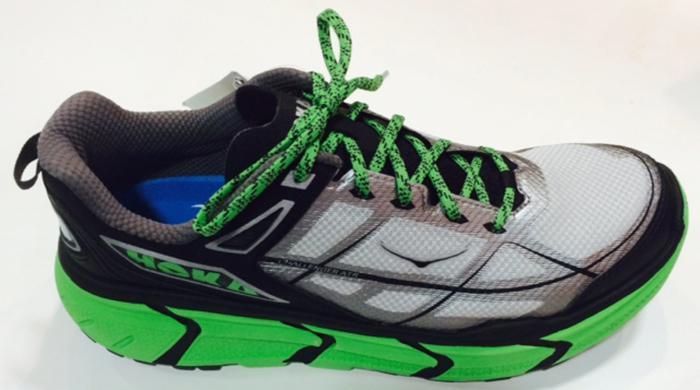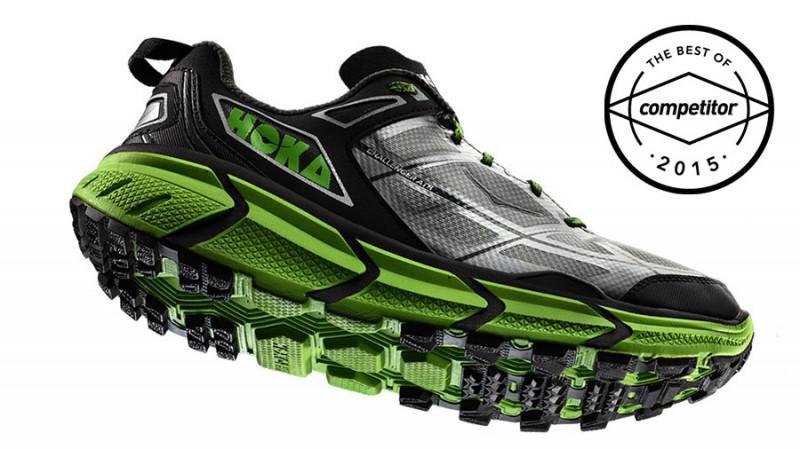The first image is the image on the left, the second image is the image on the right. Given the left and right images, does the statement "The image contains two brightly colored shoes stacked on top of eachother." hold true? Answer yes or no. No. The first image is the image on the left, the second image is the image on the right. Given the left and right images, does the statement "In at least one image there is one shoe that is sitting on top of another shoe." hold true? Answer yes or no. No. 